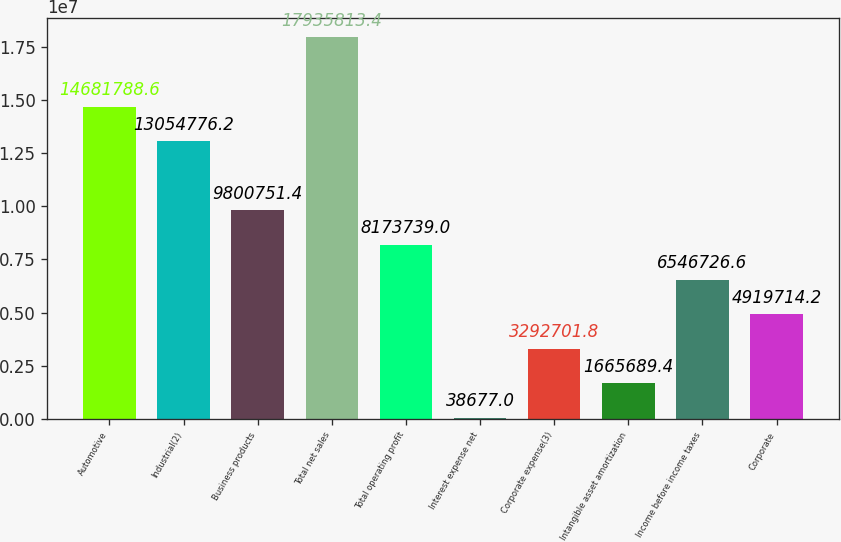Convert chart. <chart><loc_0><loc_0><loc_500><loc_500><bar_chart><fcel>Automotive<fcel>Industrial(2)<fcel>Business products<fcel>Total net sales<fcel>Total operating profit<fcel>Interest expense net<fcel>Corporate expense(3)<fcel>Intangible asset amortization<fcel>Income before income taxes<fcel>Corporate<nl><fcel>1.46818e+07<fcel>1.30548e+07<fcel>9.80075e+06<fcel>1.79358e+07<fcel>8.17374e+06<fcel>38677<fcel>3.2927e+06<fcel>1.66569e+06<fcel>6.54673e+06<fcel>4.91971e+06<nl></chart> 